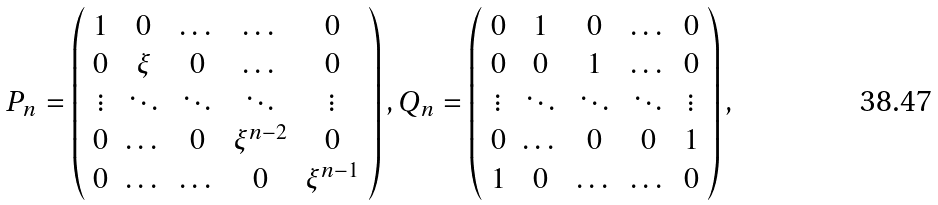Convert formula to latex. <formula><loc_0><loc_0><loc_500><loc_500>P _ { n } = \left ( \begin{array} { c c c c c } 1 & 0 & \dots & \dots & 0 \\ 0 & \xi & 0 & \dots & 0 \\ \vdots & \ddots & \ddots & \ddots & \vdots \\ 0 & \dots & 0 & \xi ^ { n - 2 } & 0 \\ 0 & \dots & \dots & 0 & \xi ^ { n - 1 } \end{array} \right ) , Q _ { n } = \left ( \begin{array} { c c c c c } 0 & 1 & 0 & \dots & 0 \\ 0 & 0 & 1 & \dots & 0 \\ { \vdots } & \ddots & \ddots & \ddots & \vdots \\ 0 & \dots & 0 & 0 & 1 \\ 1 & 0 & \dots & \dots & 0 \end{array} \right ) ,</formula> 